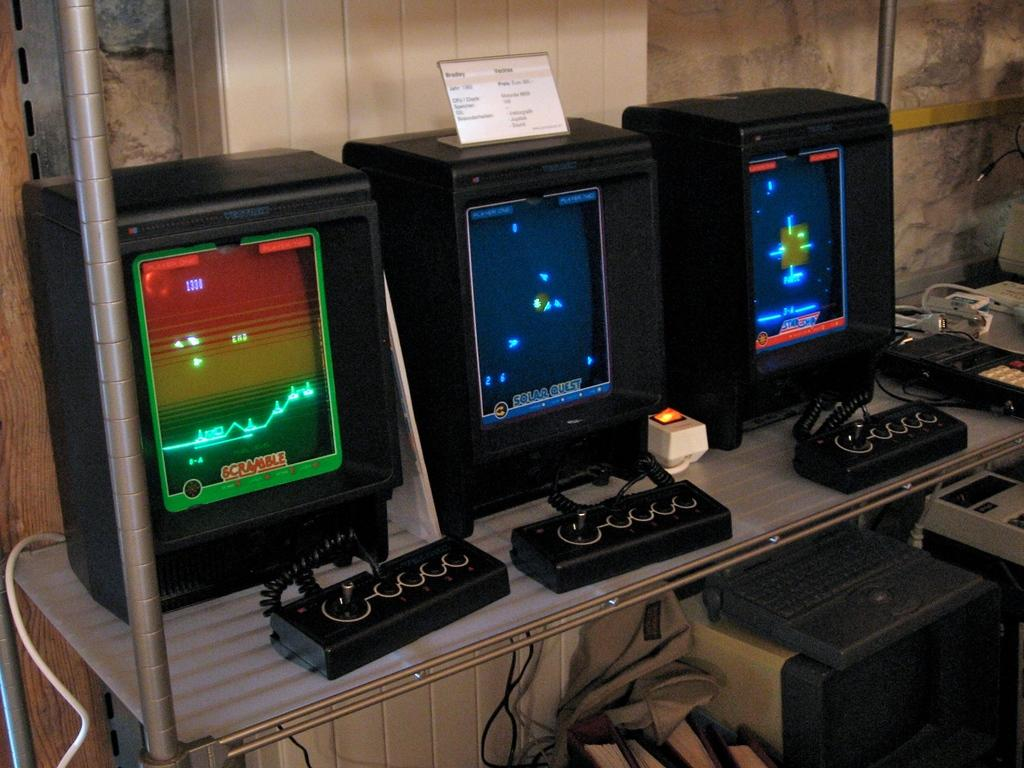Provide a one-sentence caption for the provided image. An old style game console on the left has a screen with scramble at the bottom. 